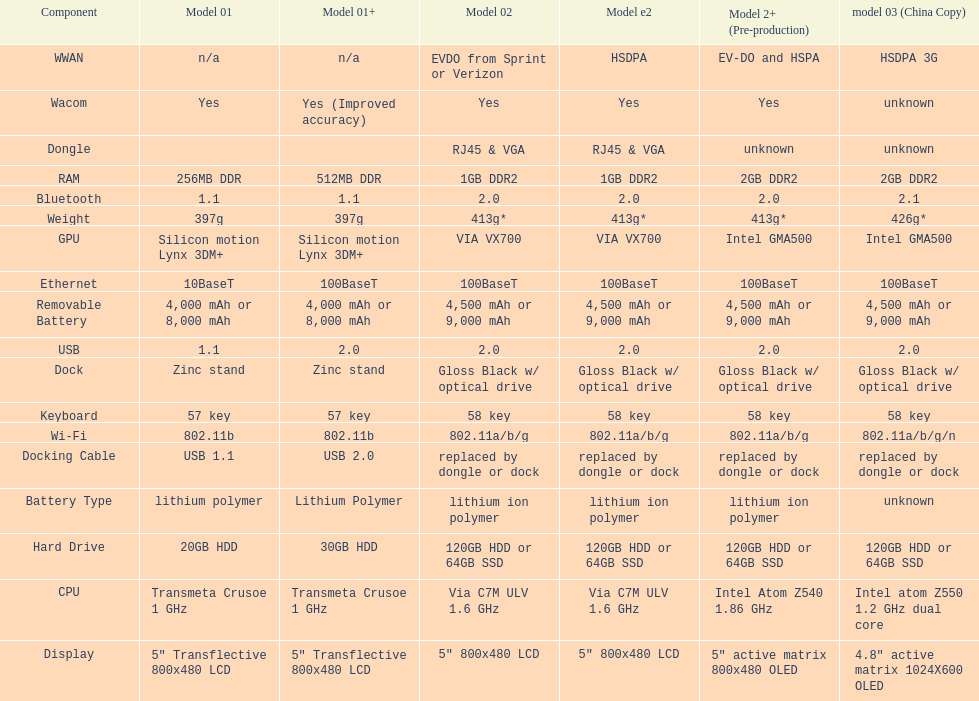What is the next highest hard drive available after the 30gb model? 64GB SSD. 